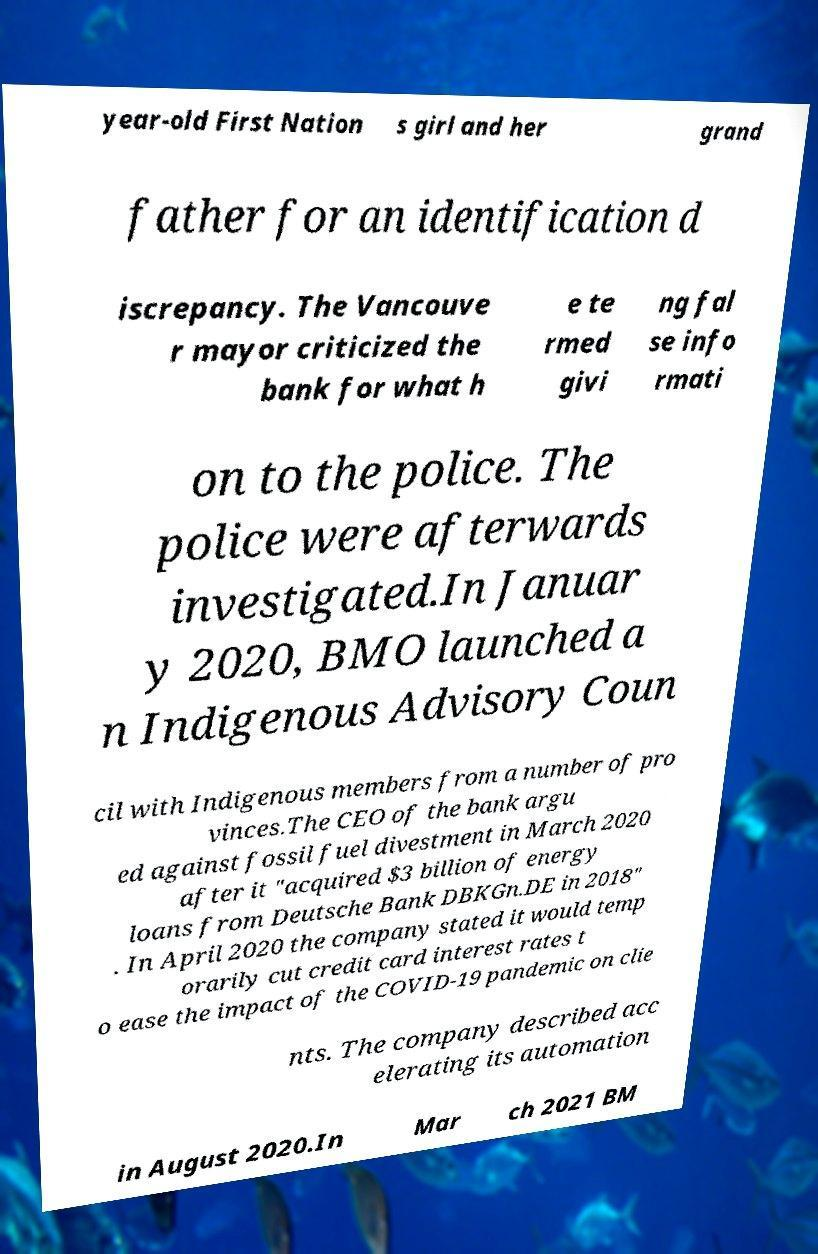Please identify and transcribe the text found in this image. year-old First Nation s girl and her grand father for an identification d iscrepancy. The Vancouve r mayor criticized the bank for what h e te rmed givi ng fal se info rmati on to the police. The police were afterwards investigated.In Januar y 2020, BMO launched a n Indigenous Advisory Coun cil with Indigenous members from a number of pro vinces.The CEO of the bank argu ed against fossil fuel divestment in March 2020 after it "acquired $3 billion of energy loans from Deutsche Bank DBKGn.DE in 2018" . In April 2020 the company stated it would temp orarily cut credit card interest rates t o ease the impact of the COVID-19 pandemic on clie nts. The company described acc elerating its automation in August 2020.In Mar ch 2021 BM 